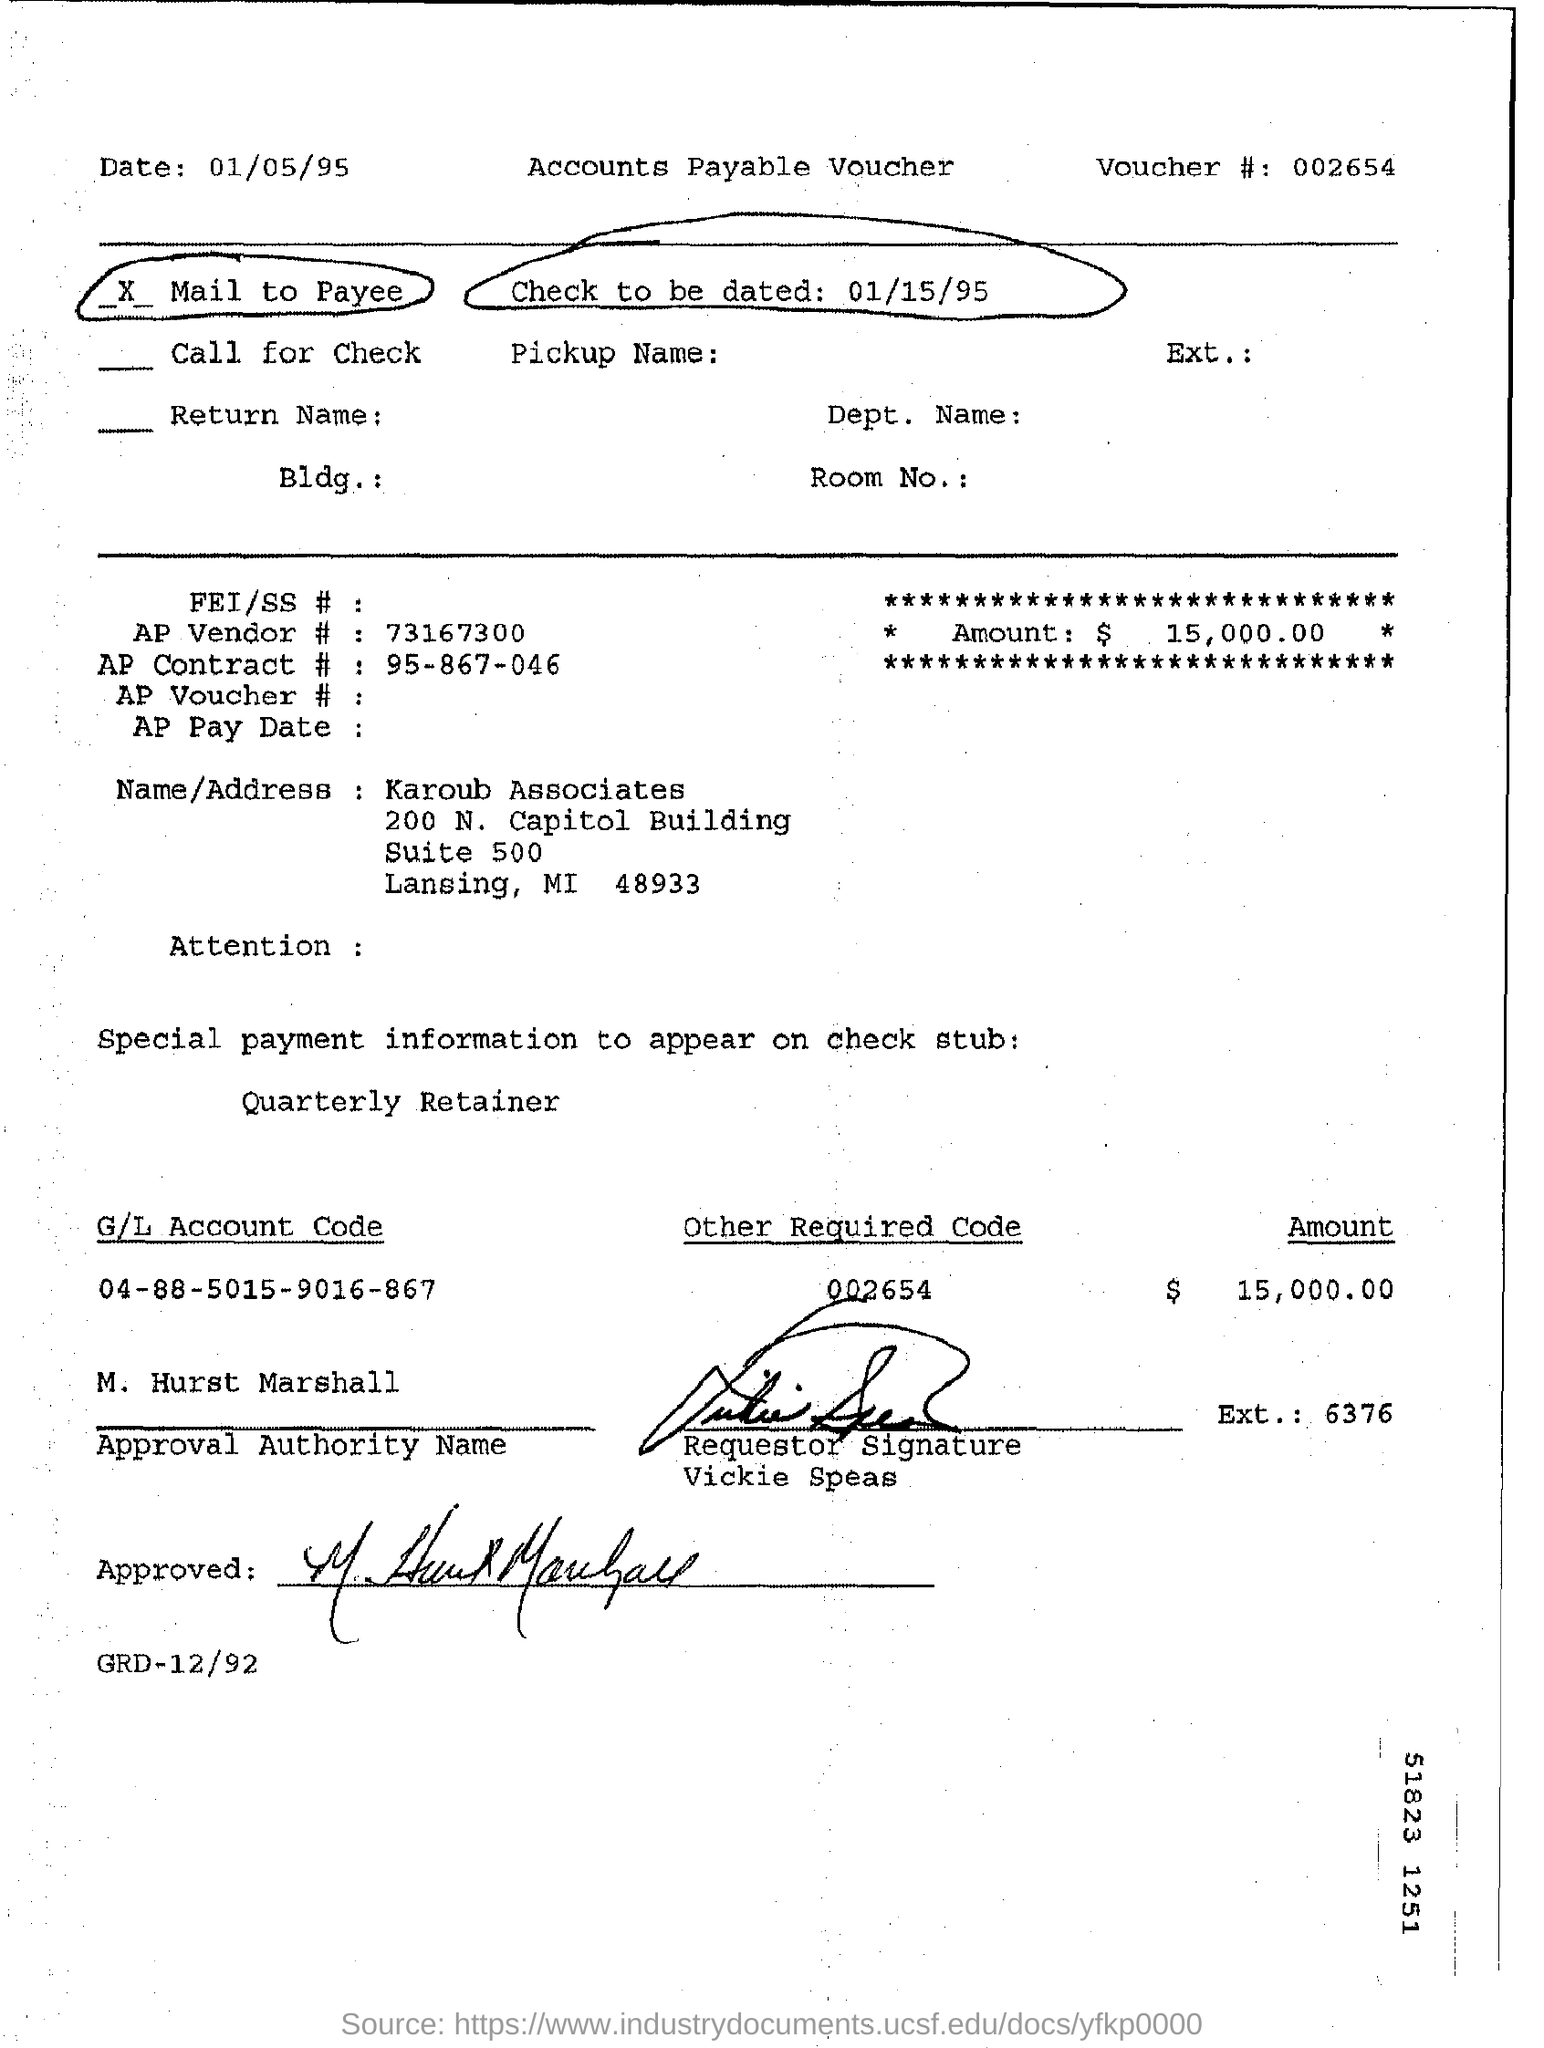Indicate a few pertinent items in this graphic. The check is to be dated on January 15, 1995. The G/L account code mentioned is 04-88-5015-9016-867...," which is a string of numbers and letters that serves as a unique identifier for a financial transaction in a company's accounting system. The voucher number is 002654... The amount specified is $15,000.00. 